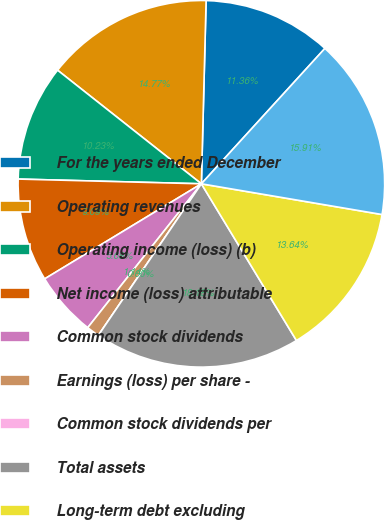<chart> <loc_0><loc_0><loc_500><loc_500><pie_chart><fcel>For the years ended December<fcel>Operating revenues<fcel>Operating income (loss) (b)<fcel>Net income (loss) attributable<fcel>Common stock dividends<fcel>Earnings (loss) per share -<fcel>Common stock dividends per<fcel>Total assets<fcel>Long-term debt excluding<fcel>Total Ameren Corporation<nl><fcel>11.36%<fcel>14.77%<fcel>10.23%<fcel>9.09%<fcel>5.68%<fcel>1.14%<fcel>0.0%<fcel>18.18%<fcel>13.64%<fcel>15.91%<nl></chart> 